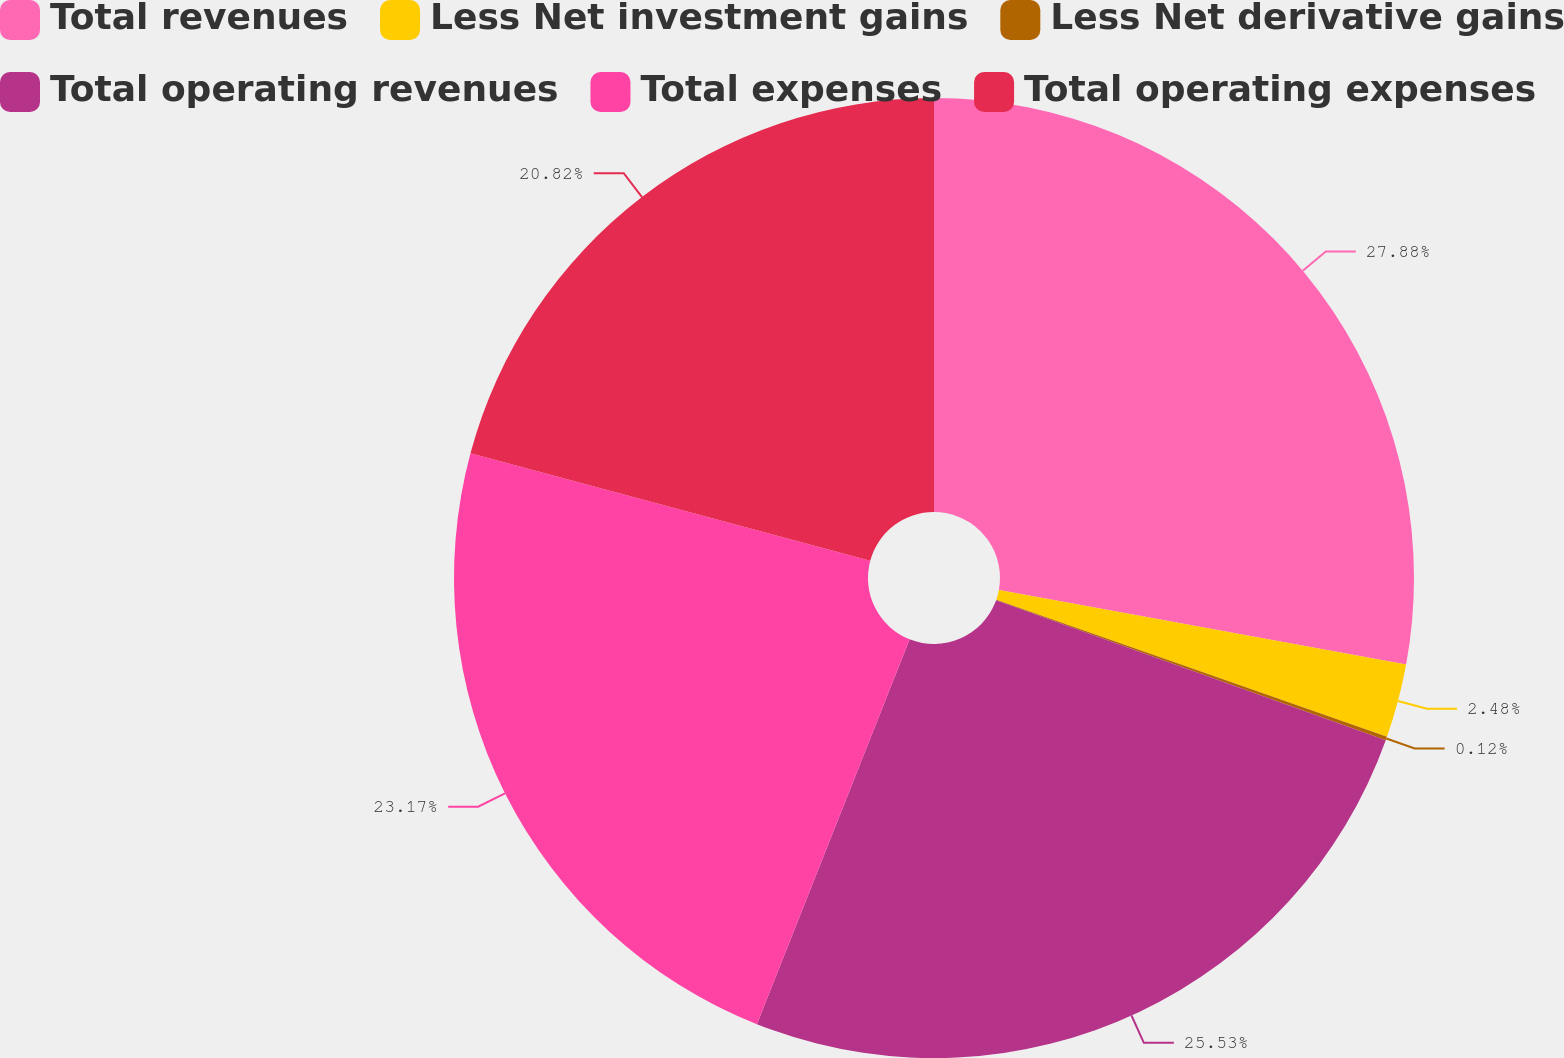Convert chart. <chart><loc_0><loc_0><loc_500><loc_500><pie_chart><fcel>Total revenues<fcel>Less Net investment gains<fcel>Less Net derivative gains<fcel>Total operating revenues<fcel>Total expenses<fcel>Total operating expenses<nl><fcel>27.89%<fcel>2.48%<fcel>0.12%<fcel>25.53%<fcel>23.17%<fcel>20.82%<nl></chart> 